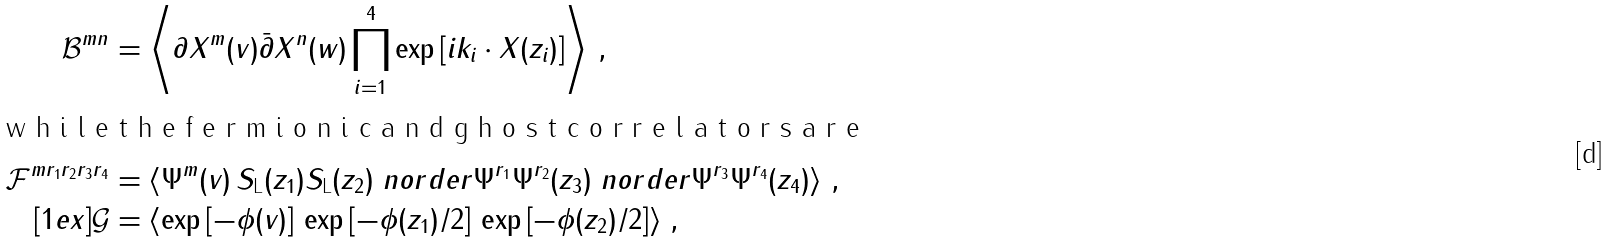Convert formula to latex. <formula><loc_0><loc_0><loc_500><loc_500>\mathcal { B } ^ { { m } { n } } & = \left \langle \partial X ^ { m } ( v ) \bar { \partial } X ^ { n } ( w ) \prod _ { i = 1 } ^ { 4 } \exp \left [ i k _ { i } \cdot X ( z _ { i } ) \right ] \right \rangle \, , \intertext { w h i l e t h e f e r m i o n i c a n d g h o s t c o r r e l a t o r s a r e } \mathcal { F } ^ { { m } r _ { 1 } r _ { 2 } r _ { 3 } r _ { 4 } } & = \left \langle \Psi ^ { m } ( v ) \, S _ { \text {L} } ( z _ { 1 } ) S _ { \text {L} } ( z _ { 2 } ) \ n o r d e r { \Psi ^ { r _ { 1 } } \Psi ^ { r _ { 2 } } } { ( z _ { 3 } ) } \ n o r d e r { \Psi ^ { r _ { 3 } } \Psi ^ { r _ { 4 } } } { ( z _ { 4 } ) } \right \rangle \, , \\ [ 1 e x ] \mathcal { G } & = \left \langle \exp \left [ - \phi ( v ) \right ] \, \exp \left [ - \phi ( z _ { 1 } ) / 2 \right ] \, \exp \left [ - \phi ( z _ { 2 } ) / 2 \right ] \right \rangle \, ,</formula> 